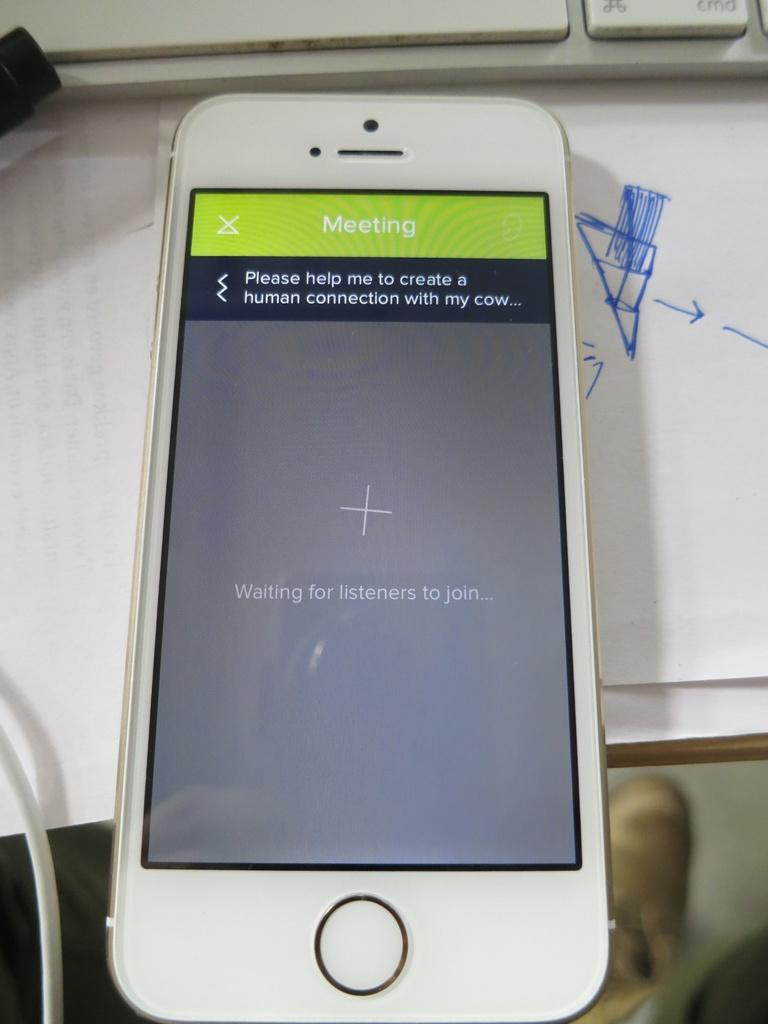<image>
Offer a succinct explanation of the picture presented. A white phone is on a desk and it is open to a meeting screen. 